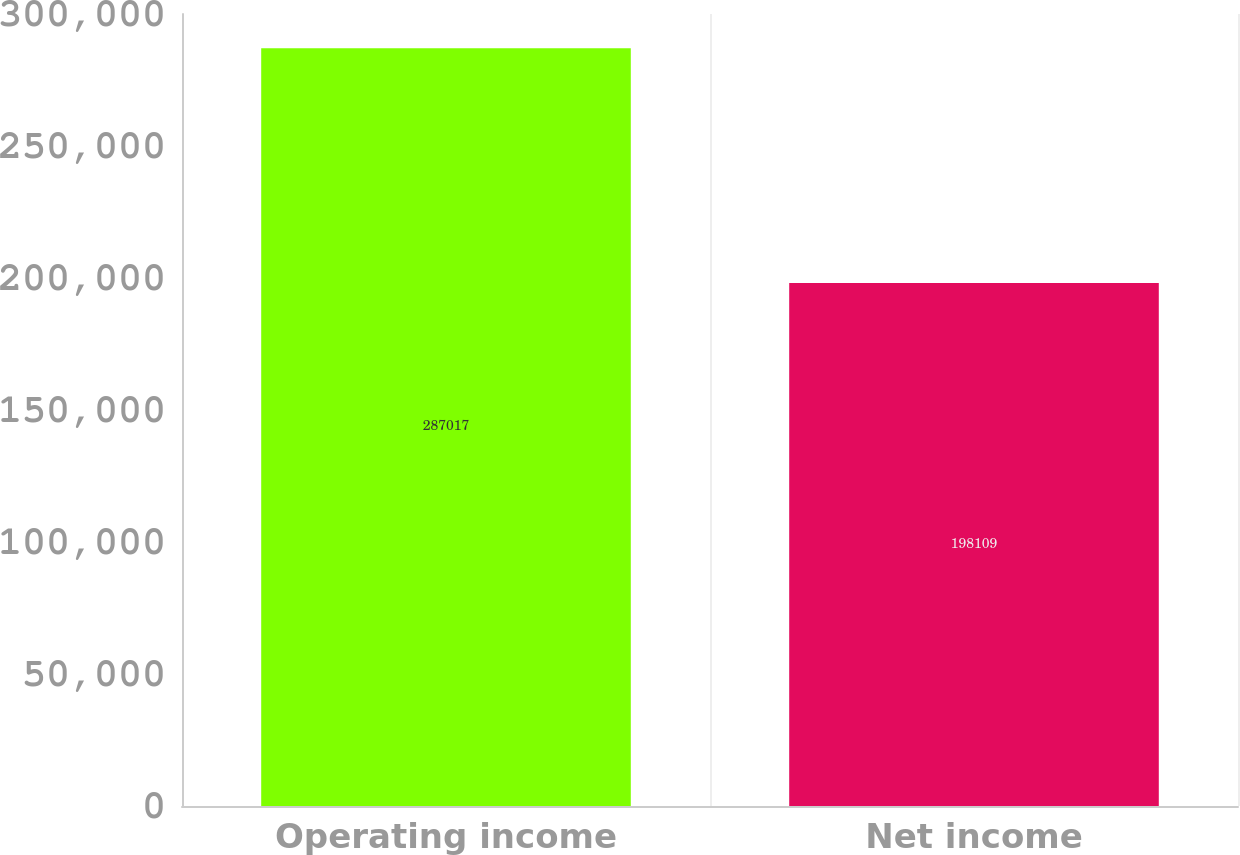<chart> <loc_0><loc_0><loc_500><loc_500><bar_chart><fcel>Operating income<fcel>Net income<nl><fcel>287017<fcel>198109<nl></chart> 